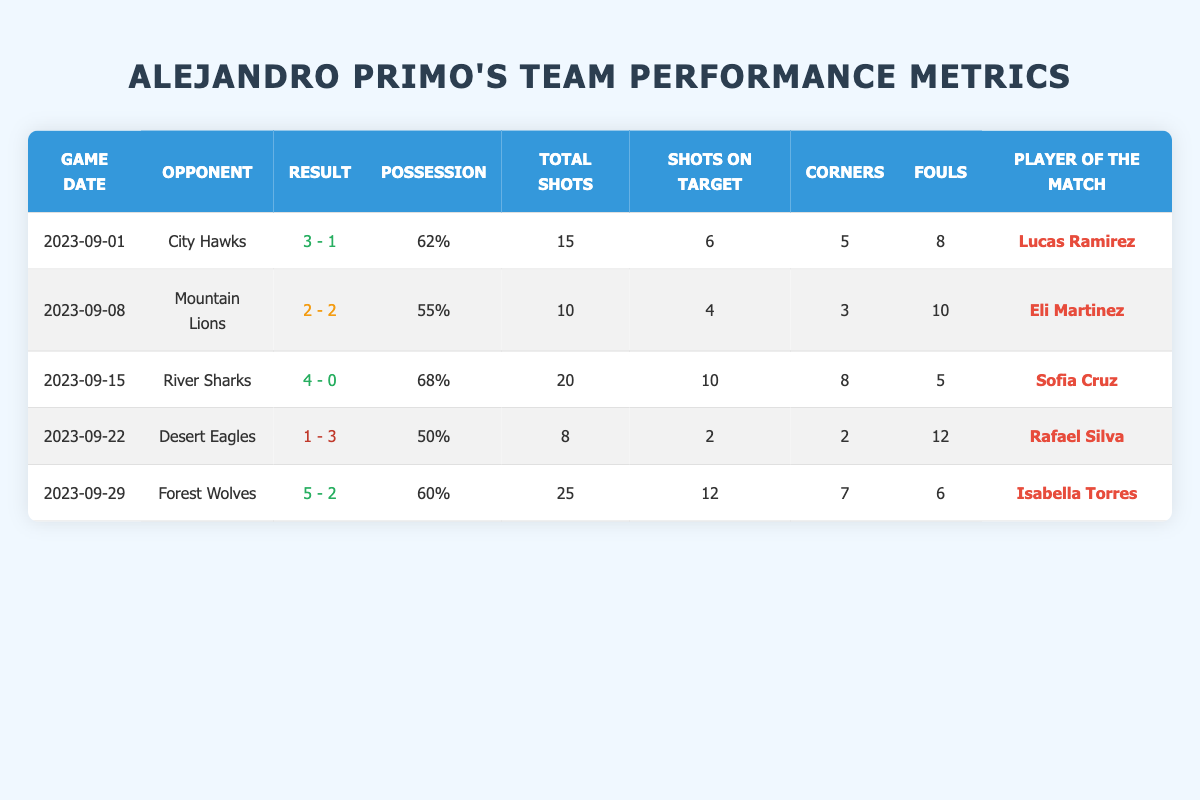What was the possession percentage in the game against the City Hawks? In the table, under the "Possession" column for the game against the City Hawks (on 2023-09-01), the possession percentage is listed as 62%.
Answer: 62% Who was the player of the match for the game on September 22? In the row corresponding to the game on September 22, the "Player of the Match" column lists Rafael Silva for the game against the Desert Eagles.
Answer: Rafael Silva How many total shots were taken in the game against the River Sharks? Looking at the row for the River Sharks game (2023-09-15), the "Total Shots" column shows a value of 20.
Answer: 20 What was the goal difference in the game against the Mountain Lions? The goals scored against the Mountain Lions were 2, and the goals conceded were also 2. The difference is 2 - 2 = 0, indicating a draw.
Answer: 0 How many corners were won in the game against the Forest Wolves? Referring to the row for the Forest Wolves game on September 29, it shows that 7 corners were won in that match.
Answer: 7 What is the average number of goals scored across all games? The goals scored in each game are: 3, 2, 4, 1, and 5. Adding these gives 3 + 2 + 4 + 1 + 5 = 15. Dividing by 5 (the number of games), the average is 15 / 5 = 3.
Answer: 3 Did the team win the game against the Desert Eagles? The result for the game against the Desert Eagles was 1 - 3, which indicates that the team lost this match.
Answer: No What is the highest possession percentage achieved in a single game? The possession percentages listed are 62%, 55%, 68%, 50%, and 60%. The highest among these is 68%, which occurred in the game against the River Sharks.
Answer: 68% How many fouls were committed in total across all games? The fouls committed in each game are: 8, 10, 5, 12, and 6. Adding these gives 8 + 10 + 5 + 12 + 6 = 41 fouls in total across all games.
Answer: 41 Which game had the highest number of shots on target? The shots on target for each game are: 6 (vs City Hawks), 4 (vs Mountain Lions), 10 (vs River Sharks), 2 (vs Desert Eagles), and 12 (vs Forest Wolves). The highest is 12 in the game against the Forest Wolves.
Answer: Forest Wolves What was the result of the game against the River Sharks? In the table for the River Sharks game (2023-09-15), the result is listed as 4 - 0, indicating a win for our team.
Answer: 4 - 0 